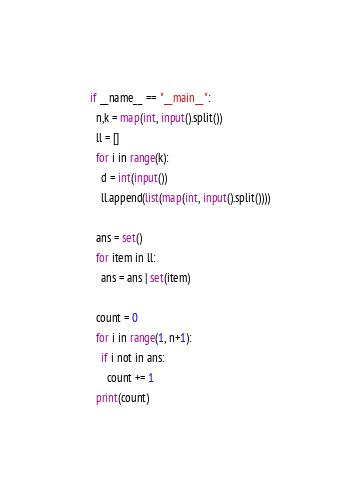Convert code to text. <code><loc_0><loc_0><loc_500><loc_500><_Python_>if __name__ == "__main__":
  n,k = map(int, input().split())
  ll = []
  for i in range(k):
    d = int(input())
    ll.append(list(map(int, input().split())))

  ans = set()
  for item in ll:
    ans = ans | set(item)

  count = 0
  for i in range(1, n+1):
    if i not in ans:
      count += 1
  print(count)
</code> 